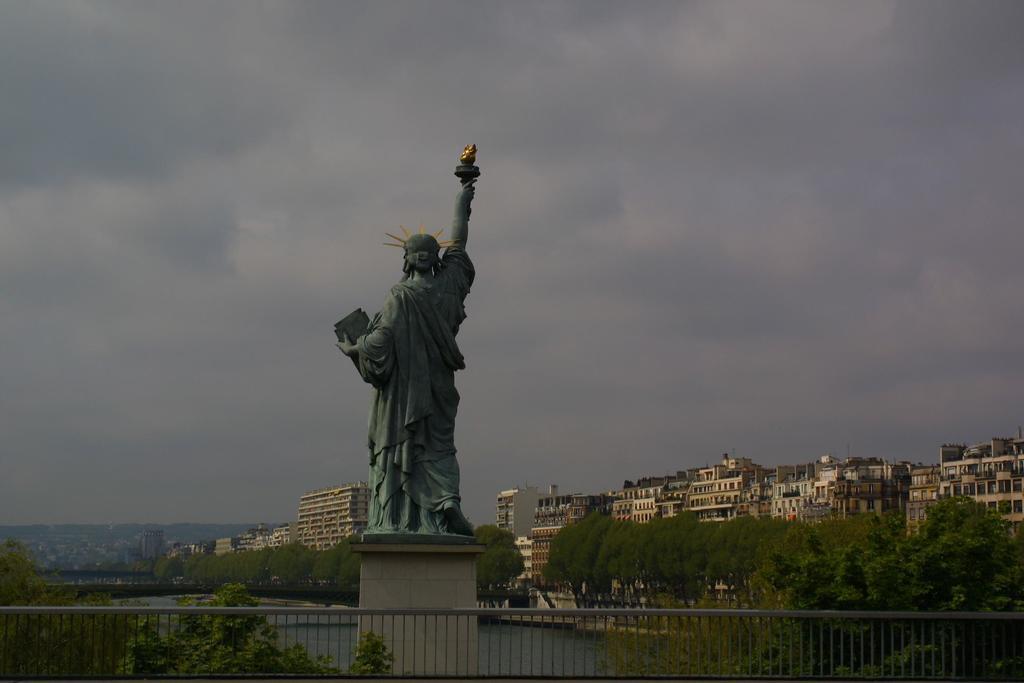Could you give a brief overview of what you see in this image? In this picture we can see a statue, fence and few trees, in the background we can see water, few buildings and clouds. 